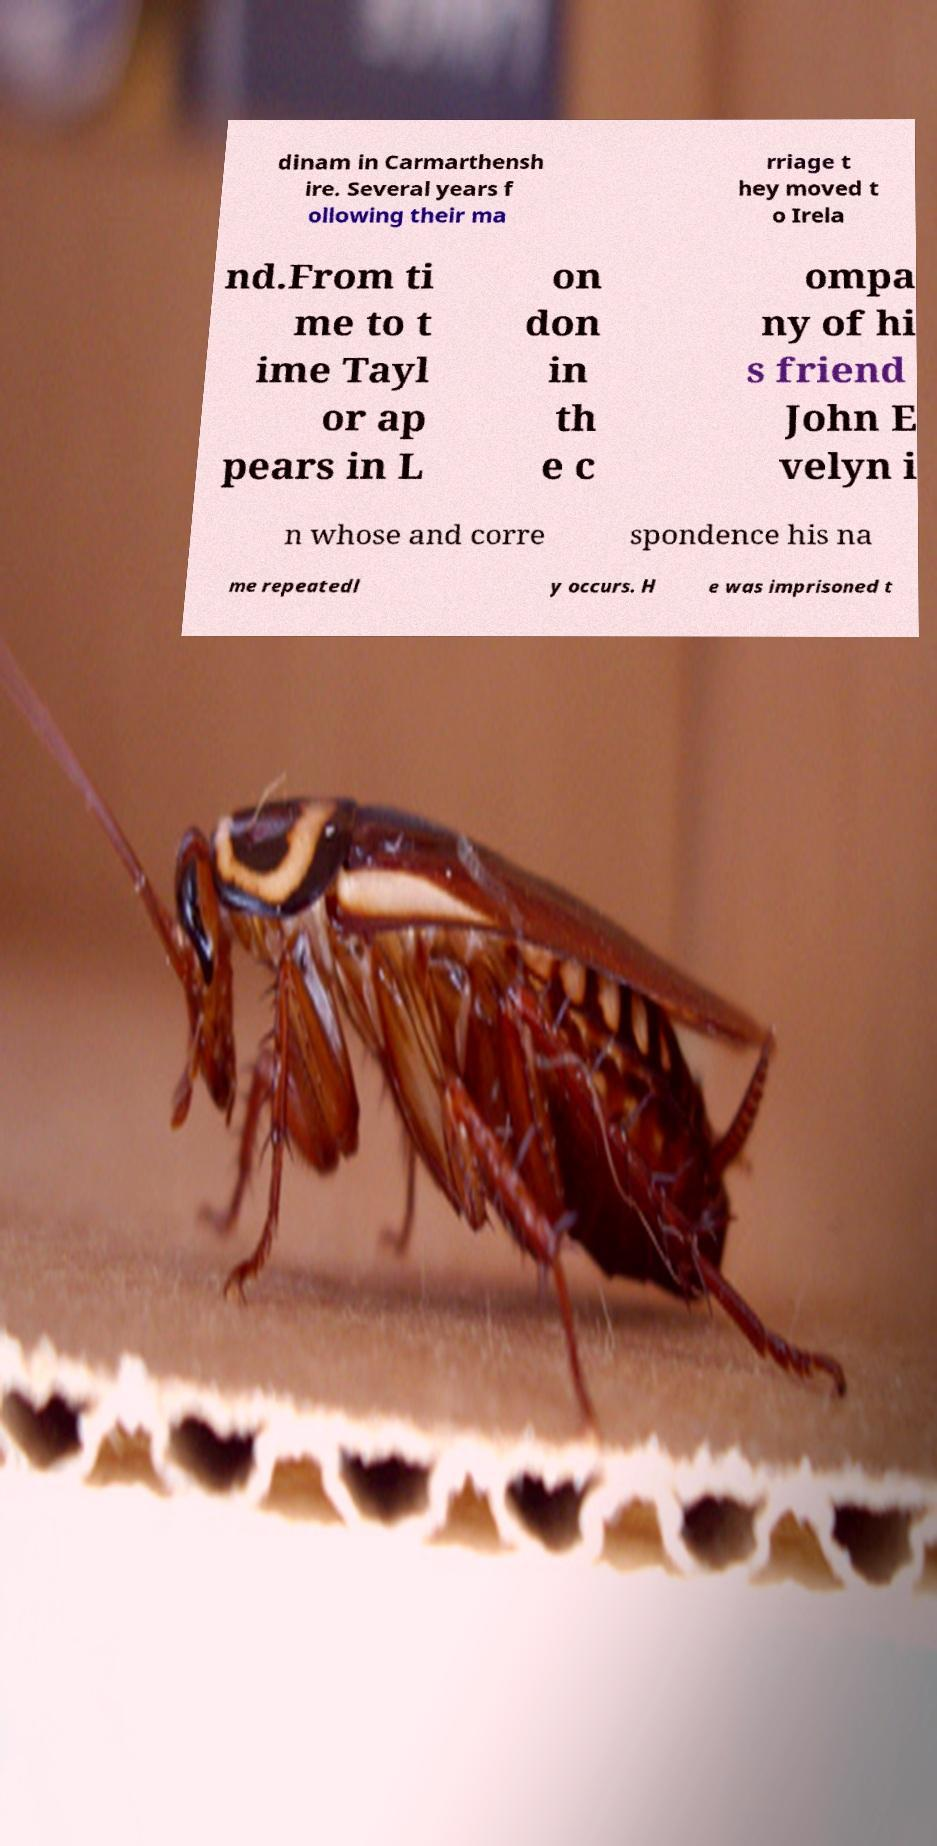Can you accurately transcribe the text from the provided image for me? dinam in Carmarthensh ire. Several years f ollowing their ma rriage t hey moved t o Irela nd.From ti me to t ime Tayl or ap pears in L on don in th e c ompa ny of hi s friend John E velyn i n whose and corre spondence his na me repeatedl y occurs. H e was imprisoned t 